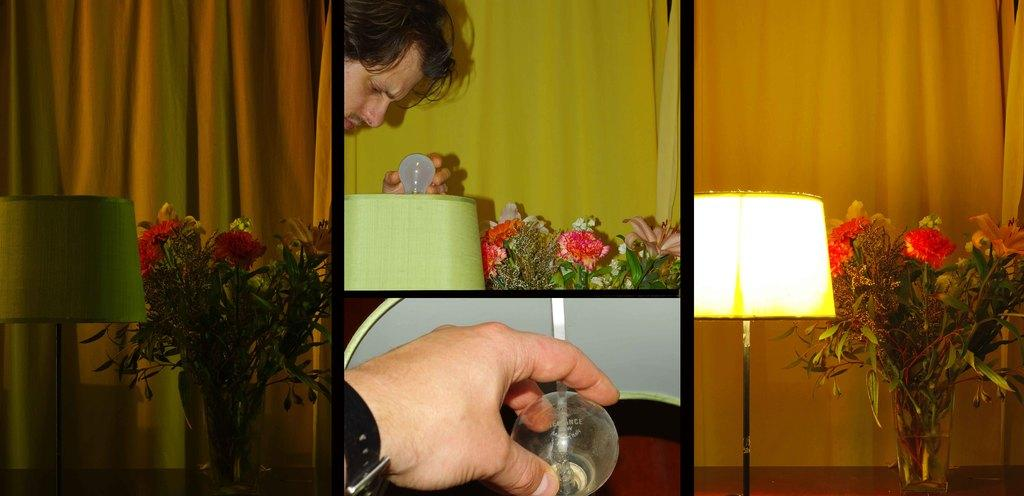Who is present in the image? There is a man in the image. What is the man holding in the image? The man is holding a bulb. What is the man doing with the bulb? The man is putting the bulb in a bed lamp. What other objects can be seen in the image? There are flower vases and bed lamps on either side of the image. What arithmetic problem is the man trying to solve in the image? There is no arithmetic problem present in the image; the man is focused on putting a bulb in a bed lamp. How does the man communicate with the rail in the image? There is no rail present in the image, and the man is not communicating with any object or person. 